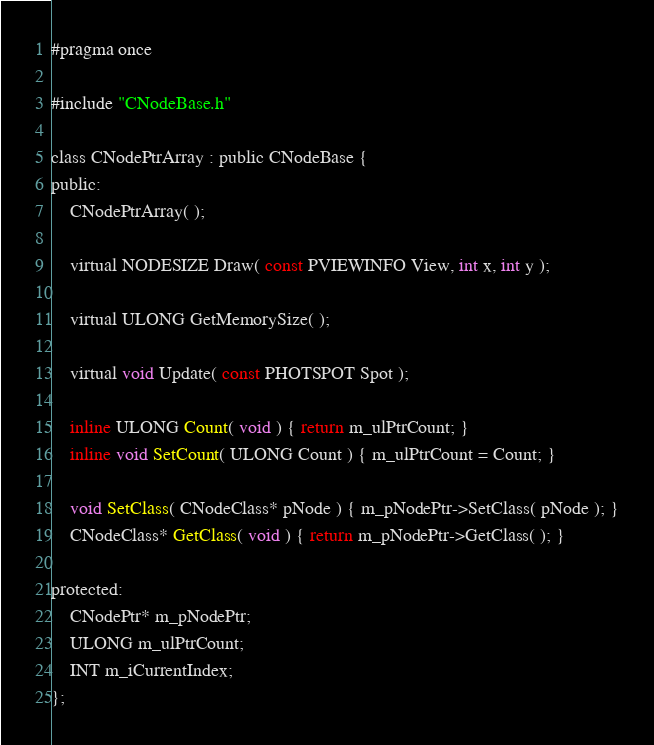Convert code to text. <code><loc_0><loc_0><loc_500><loc_500><_C_>#pragma once

#include "CNodeBase.h"

class CNodePtrArray : public CNodeBase {
public:
    CNodePtrArray( );

    virtual NODESIZE Draw( const PVIEWINFO View, int x, int y );

    virtual ULONG GetMemorySize( );

    virtual void Update( const PHOTSPOT Spot );

    inline ULONG Count( void ) { return m_ulPtrCount; }
    inline void SetCount( ULONG Count ) { m_ulPtrCount = Count; }

    void SetClass( CNodeClass* pNode ) { m_pNodePtr->SetClass( pNode ); }
    CNodeClass* GetClass( void ) { return m_pNodePtr->GetClass( ); }

protected:
    CNodePtr* m_pNodePtr;
    ULONG m_ulPtrCount;
    INT m_iCurrentIndex;
};

</code> 